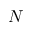Convert formula to latex. <formula><loc_0><loc_0><loc_500><loc_500>N</formula> 